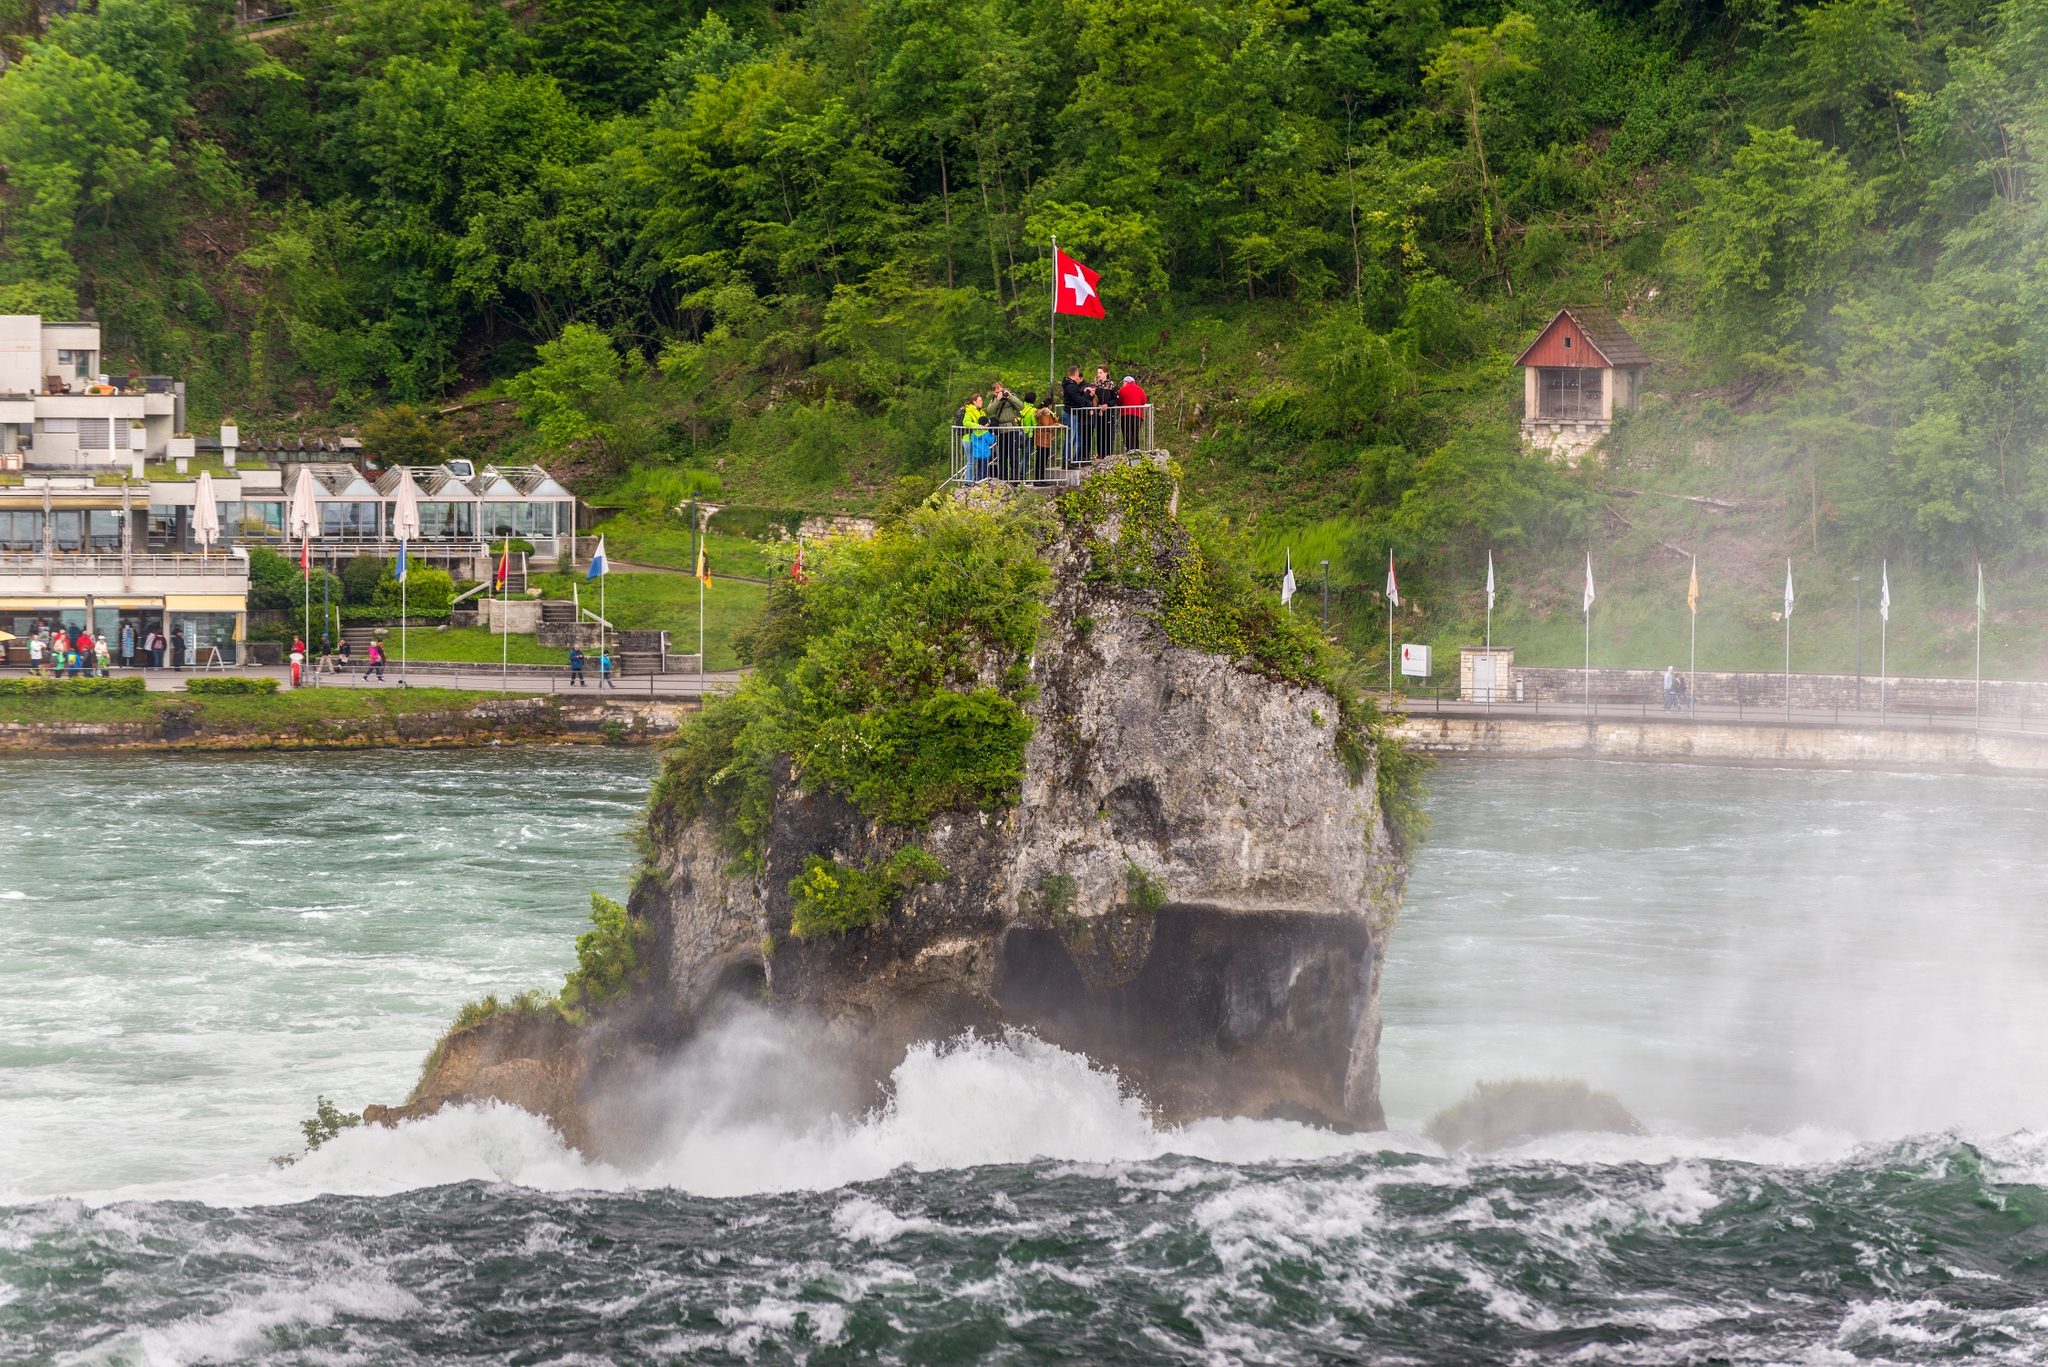What do you see happening in this image? The image showcases the spectacular Rhine Falls, a prominent natural landmark in Switzerland known for its breathtaking beauty and immense water flow. The central rock formation, adorned with a vibrant Swiss flag, stands as a bold symbol of national pride against the backdrop of rushing waterfalls. The surrounding lush greenery accentuates the area's natural beauty, while the quaint wooden hut on the right serves as a historical point of interest, possibly used for monitoring or tours. This scenic view is captured from an elevated position, highlighting the expansive and dynamic nature of the falls, making it a popular spot for tourists and nature lovers alike. 